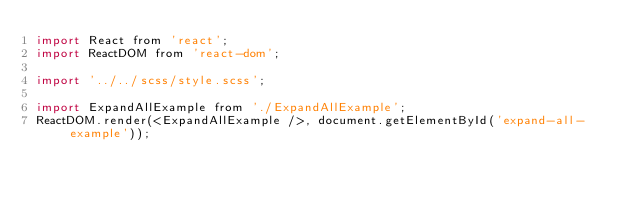<code> <loc_0><loc_0><loc_500><loc_500><_JavaScript_>import React from 'react';
import ReactDOM from 'react-dom';

import '../../scss/style.scss';

import ExpandAllExample from './ExpandAllExample';
ReactDOM.render(<ExpandAllExample />, document.getElementById('expand-all-example'));
</code> 